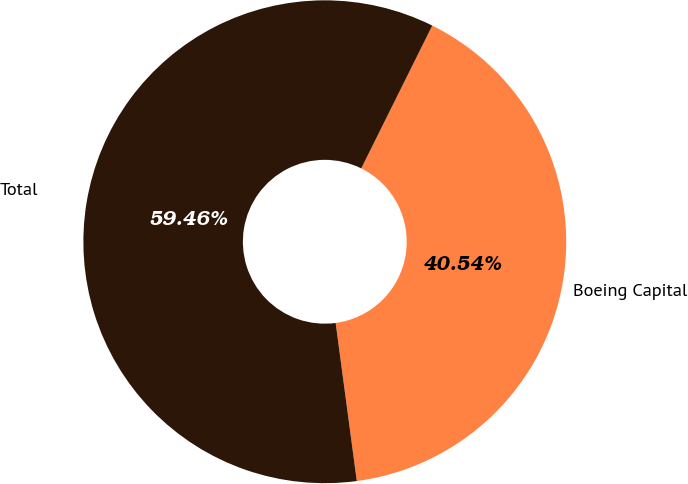Convert chart to OTSL. <chart><loc_0><loc_0><loc_500><loc_500><pie_chart><fcel>Boeing Capital<fcel>Total<nl><fcel>40.54%<fcel>59.46%<nl></chart> 